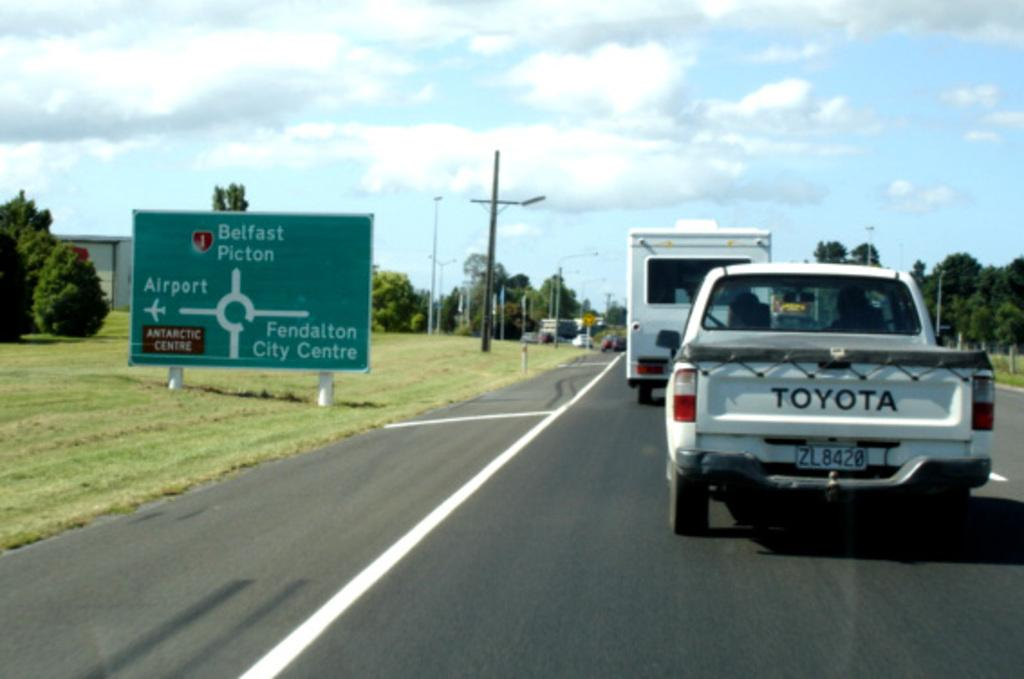What can be seen on the road in the image? There are vehicles on the road in the image. What is located on the left side of the image? There is a board on the left side of the image. What objects are visible in the image that are used for support or guidance? Poles are visible in the image. What can be seen in the background of the image? There are trees and the sky visible in the background of the image. What is the opinion of the calculator in the middle of the image? There is no calculator present in the image, so it cannot have an opinion. 